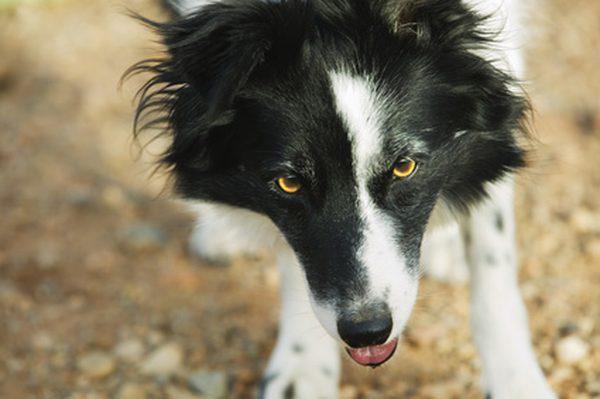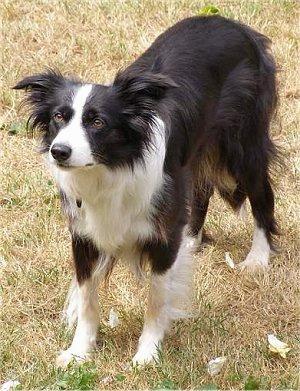The first image is the image on the left, the second image is the image on the right. Given the left and right images, does the statement "Each image shows an angry-looking dog baring its fangs, and the dogs in the images face the same general direction." hold true? Answer yes or no. No. The first image is the image on the left, the second image is the image on the right. For the images shown, is this caption "Both dogs are barring their teeth in aggression." true? Answer yes or no. No. 